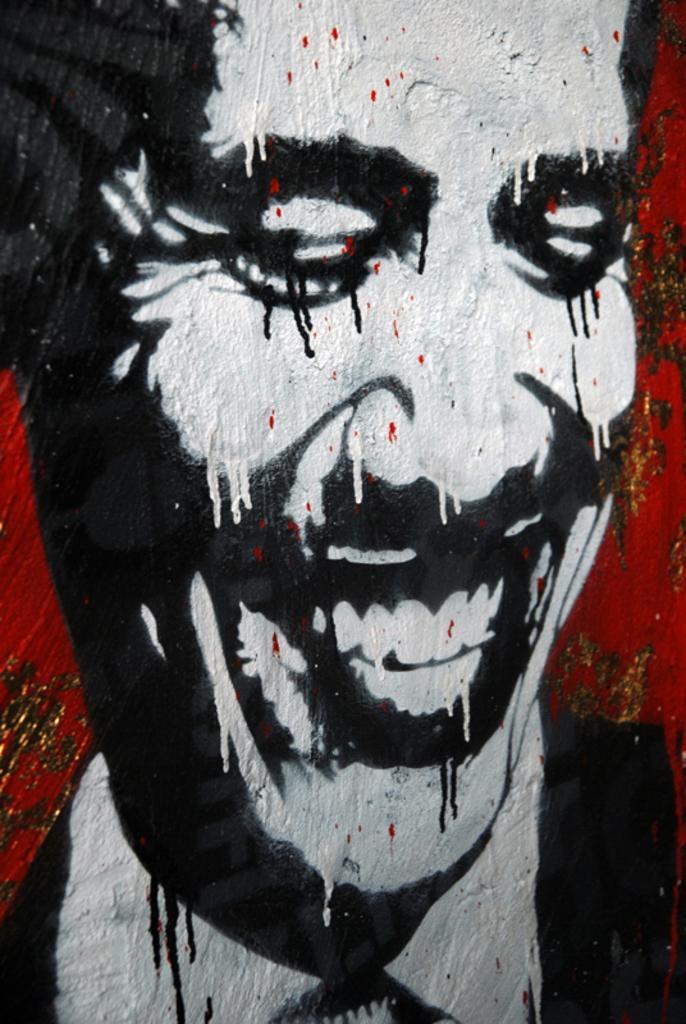How would you summarize this image in a sentence or two? In this image, we can see a person's painting on the wall. 